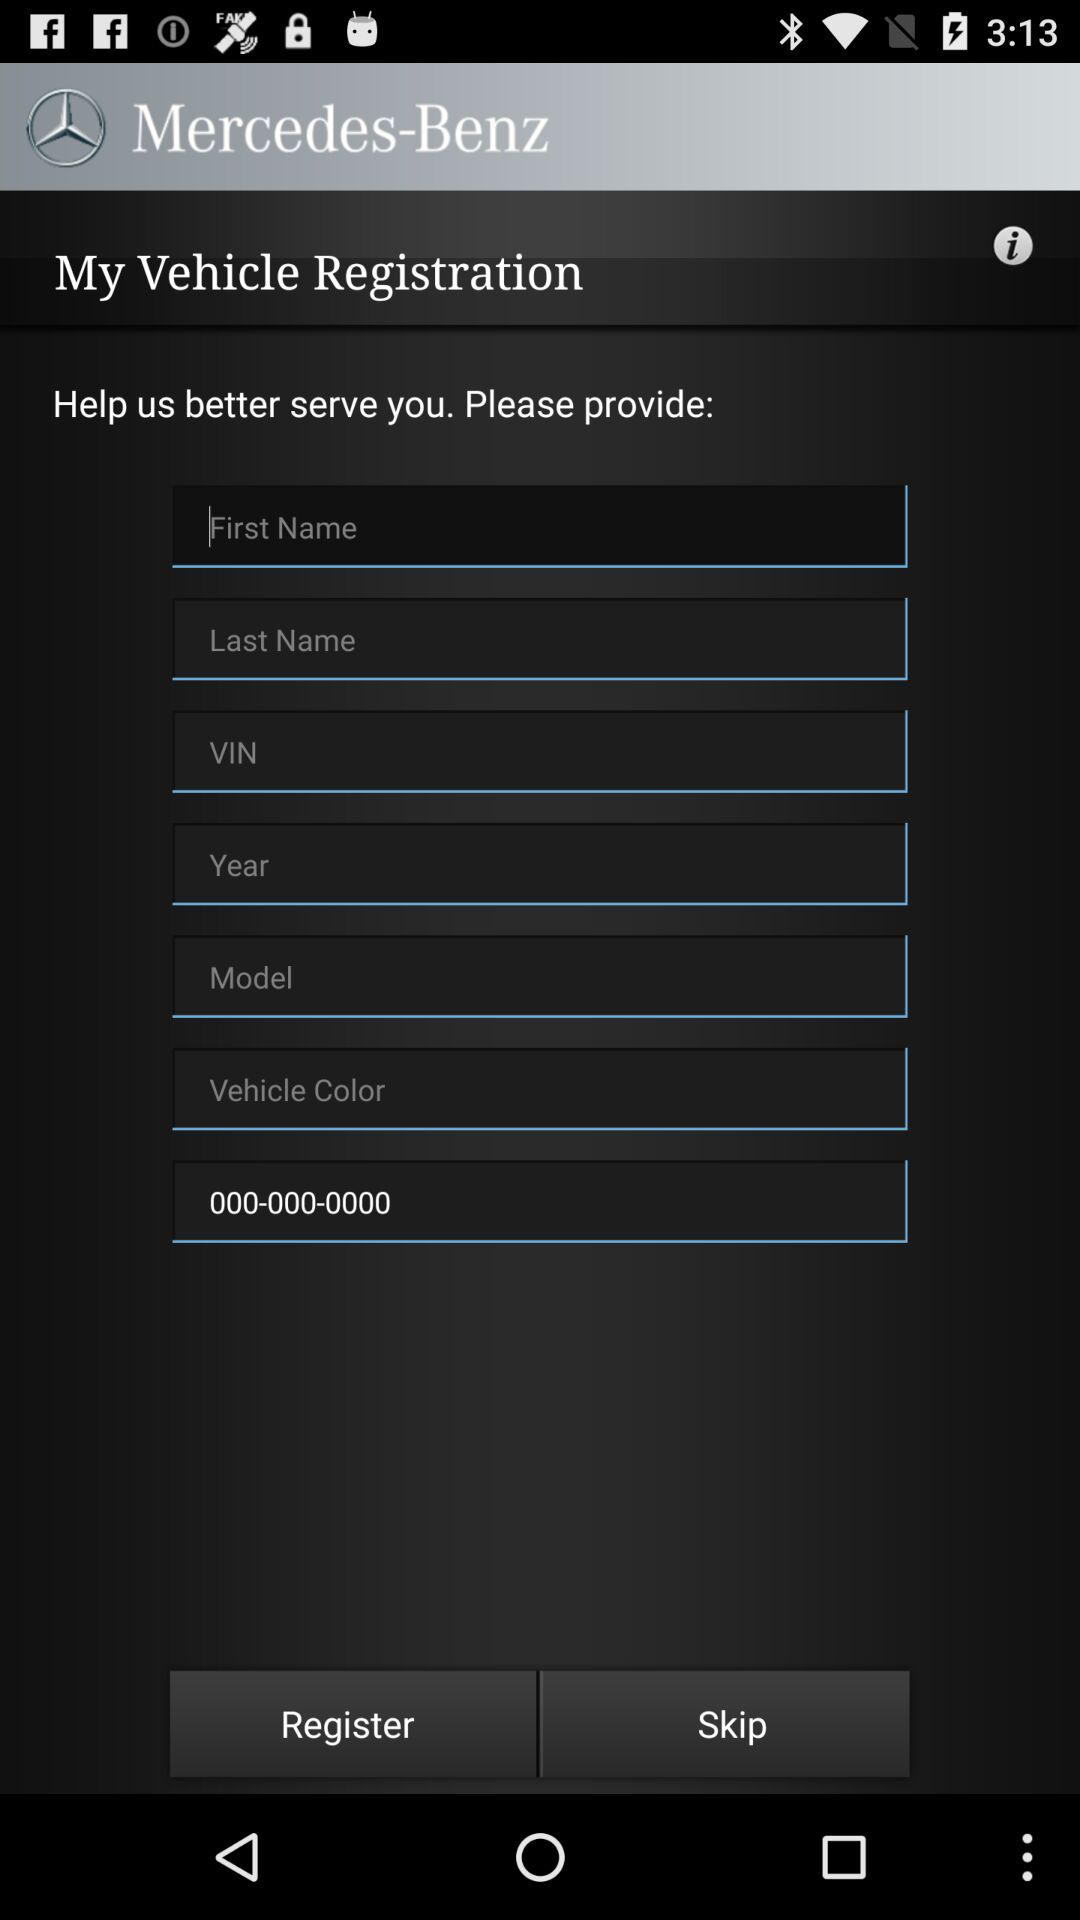What is the name of the application? The name of the application is "Mercedes-Benz". 